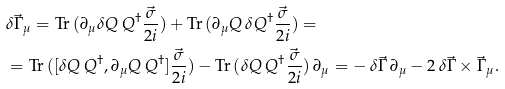<formula> <loc_0><loc_0><loc_500><loc_500>& \delta \vec { \Gamma } _ { \mu } = \text {Tr} \, ( \partial _ { \mu } \delta Q \, Q ^ { \dagger } \frac { \vec { \sigma } } { 2 i } ) + \text {Tr} \, ( \partial _ { \mu } Q \, \delta Q ^ { \dagger } \frac { \vec { \sigma } } { 2 i } ) = \\ & = \text {Tr} \, ( [ \delta Q \, Q ^ { \dagger } , \partial _ { \mu } Q \, Q ^ { \dagger } ] \frac { \vec { \sigma } } { 2 i } ) - \text {Tr} \, ( \delta Q \, Q ^ { \dagger } \frac { \vec { \sigma } } { 2 i } ) \, \partial _ { \mu } = - \, \delta \vec { \Gamma } \, \partial _ { \mu } - 2 \, \delta \vec { \Gamma } \times \vec { \Gamma } _ { \mu } .</formula> 